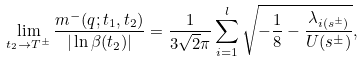Convert formula to latex. <formula><loc_0><loc_0><loc_500><loc_500>\lim _ { t _ { 2 } \to T ^ { \pm } } \frac { m ^ { - } ( q ; t _ { 1 } , t _ { 2 } ) } { | \ln \beta ( t _ { 2 } ) | } = \frac { 1 } { 3 \sqrt { 2 } \pi } \sum _ { i = 1 } ^ { l } \sqrt { - \frac { 1 } { 8 } - \frac { \lambda _ { i ( s ^ { \pm } ) } } { U ( s ^ { \pm } ) } } ,</formula> 